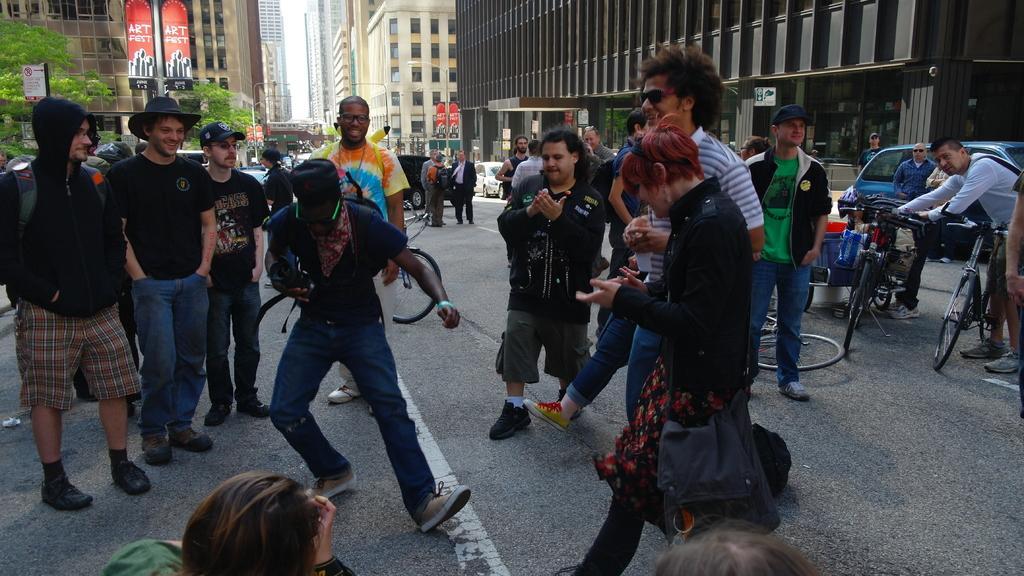Can you describe this image briefly? This picture shows few people standing and a man holding bicycles with his hands and a man dancing and we see women wore a handbag and couple of them wore caps on their heads and we see buildings and trees and a man wore hat on his head. 